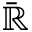<formula> <loc_0><loc_0><loc_500><loc_500>\bar { \mathbb { R } }</formula> 